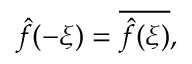Convert formula to latex. <formula><loc_0><loc_0><loc_500><loc_500>{ \hat { f } } ( - \xi ) = { \overline { { { \hat { f } } ( \xi ) } } } ,</formula> 